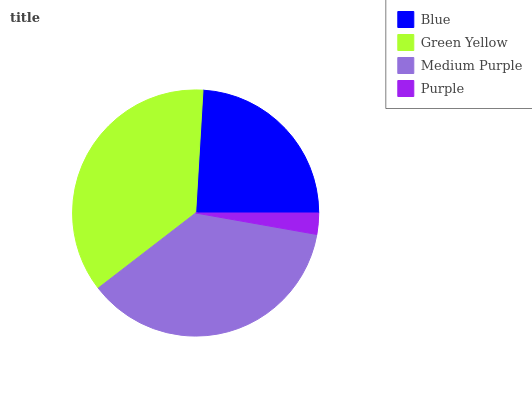Is Purple the minimum?
Answer yes or no. Yes. Is Medium Purple the maximum?
Answer yes or no. Yes. Is Green Yellow the minimum?
Answer yes or no. No. Is Green Yellow the maximum?
Answer yes or no. No. Is Green Yellow greater than Blue?
Answer yes or no. Yes. Is Blue less than Green Yellow?
Answer yes or no. Yes. Is Blue greater than Green Yellow?
Answer yes or no. No. Is Green Yellow less than Blue?
Answer yes or no. No. Is Green Yellow the high median?
Answer yes or no. Yes. Is Blue the low median?
Answer yes or no. Yes. Is Blue the high median?
Answer yes or no. No. Is Green Yellow the low median?
Answer yes or no. No. 